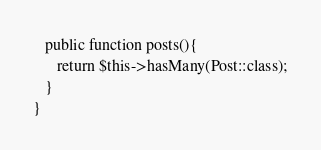<code> <loc_0><loc_0><loc_500><loc_500><_PHP_>
   public function posts(){
      return $this->hasMany(Post::class);
   }
}
</code> 